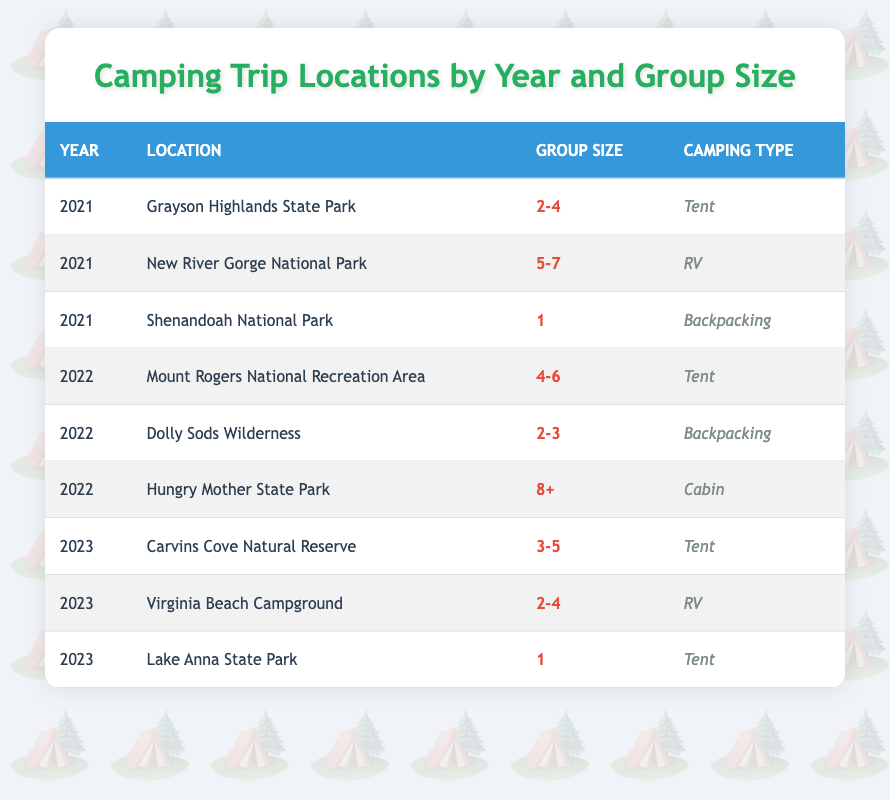What locations were visited in 2021? The table lists three locations for the year 2021: Grayson Highlands State Park, New River Gorge National Park, and Shenandoah National Park.
Answer: Grayson Highlands State Park, New River Gorge National Park, Shenandoah National Park How many different camping types were used in 2022? In 2022, the camping types listed are Tent, Backpacking, and Cabin. Thus, there are three distinct camping types used during that year.
Answer: 3 What was the most common group size in 2023? In 2023, the group sizes mentioned are 3-5, 2-4, and 1. To find the most common, we look for repeated sizes; however, we cannot conclude a single common size without specific mention of frequency. Thus, there is no statistical majority.
Answer: None How many camping trips involved a tent across all years? In the table, the camping trips involving tents occurred in 2021 (2), 2022 (1), and 2023 (2). Summing these gives us a total of 5 tent camping trips.
Answer: 5 Is there a trip listed for 2022 with a group size of 8 or more? Yes, the table shows that in 2022, there is a trip to Hungry Mother State Park with a group size of 8+.
Answer: Yes What is the average group size for camping trips in 2021? The group sizes for 2021 are 2-4, 5-7, and 1. To calculate an average, we take the midpoints of these ranges: (3 + 6 + 1) / 3 = 10 / 3 ≈ 3.33.
Answer: 3.33 Which camping location had the highest group size in 2022? The location with the highest group size in 2022 is Hungry Mother State Park, accommodating a group size of 8+. This is explicitly stated in the data.
Answer: Hungry Mother State Park How many group sizes were represented by camping trips in 2021? In 2021, the group sizes recorded were 2-4, 5-7, and 1, which indicates three distinct group sizes in total for that year.
Answer: 3 Which year had the most locations listed for camping trips? The years under consideration have 3 locations listed for 2021, 3 for 2022, and 3 for 2023. Therefore, all years share an equal number of locations (3).
Answer: None (equal across years) 